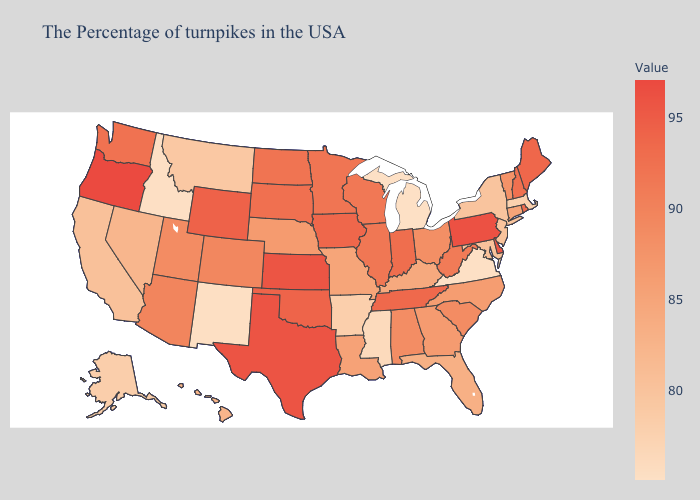Among the states that border Nevada , does California have the highest value?
Give a very brief answer. No. Does Alabama have a higher value than Tennessee?
Quick response, please. No. Does the map have missing data?
Keep it brief. No. Does Michigan have the lowest value in the USA?
Quick response, please. Yes. Does Tennessee have the highest value in the USA?
Write a very short answer. No. Is the legend a continuous bar?
Short answer required. Yes. Does Oregon have a lower value than California?
Give a very brief answer. No. 